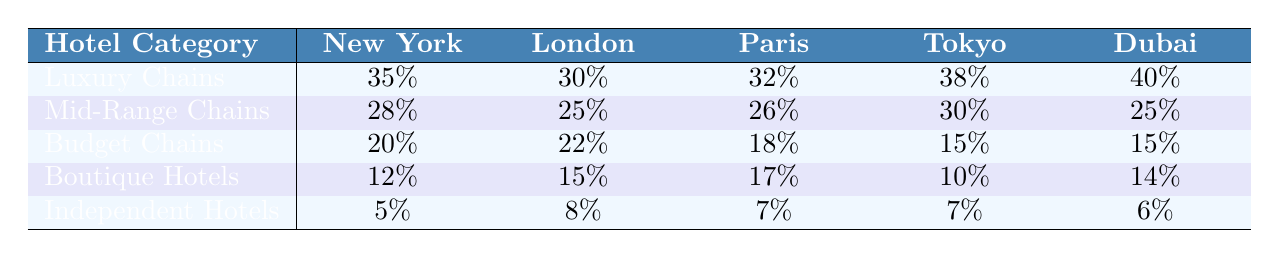What is the market share percentage of Luxury Chains in Tokyo? The table shows that the market share percentage for Luxury Chains in Tokyo is 38%.
Answer: 38% Which city has the highest market share for Mid-Range Chains? By looking at the Mid-Range Chains row, London has the highest market share at 25%.
Answer: London What is the total market share percentage for Budget Chains across all cities? Adding the values for Budget Chains: 20 + 22 + 18 + 15 + 15 = 90%.
Answer: 90% Is the market share for Independent Hotels greater than 10% in any city? The values for Independent Hotels are 5%, 8%, 7%, 7%, and 6%, indicating none exceed 10%.
Answer: No In which city do Boutique Hotels have the lowest market share, and what is that percentage? The table indicates Boutique Hotels have the lowest market share in Tokyo at 10%.
Answer: Tokyo, 10% What is the average market share percentage of Luxury Chains? The average for Luxury Chains is (35 + 30 + 32 + 38 + 40) / 5 = 35%.
Answer: 35% How does the market share of Boutique Hotels compare between New York and London? Boutique Hotels have 12% in New York and 15% in London, showing London has a higher market share.
Answer: London has a higher market share What is the difference in market share percentage for Independent Hotels between New York and Paris? The Independent Hotels show 5% in New York and 7% in Paris; the difference is 7 - 5 = 2%.
Answer: 2% Which hotel category has the lowest market share in Dubai? The table shows that Independent Hotels have the lowest market share in Dubai at 6%.
Answer: Independent Hotels, 6% What percentage of the total market share is represented by Mid-Range Chains in Paris? The Mid-Range Chains have a market share of 26% in Paris, directly stated in the table.
Answer: 26% 